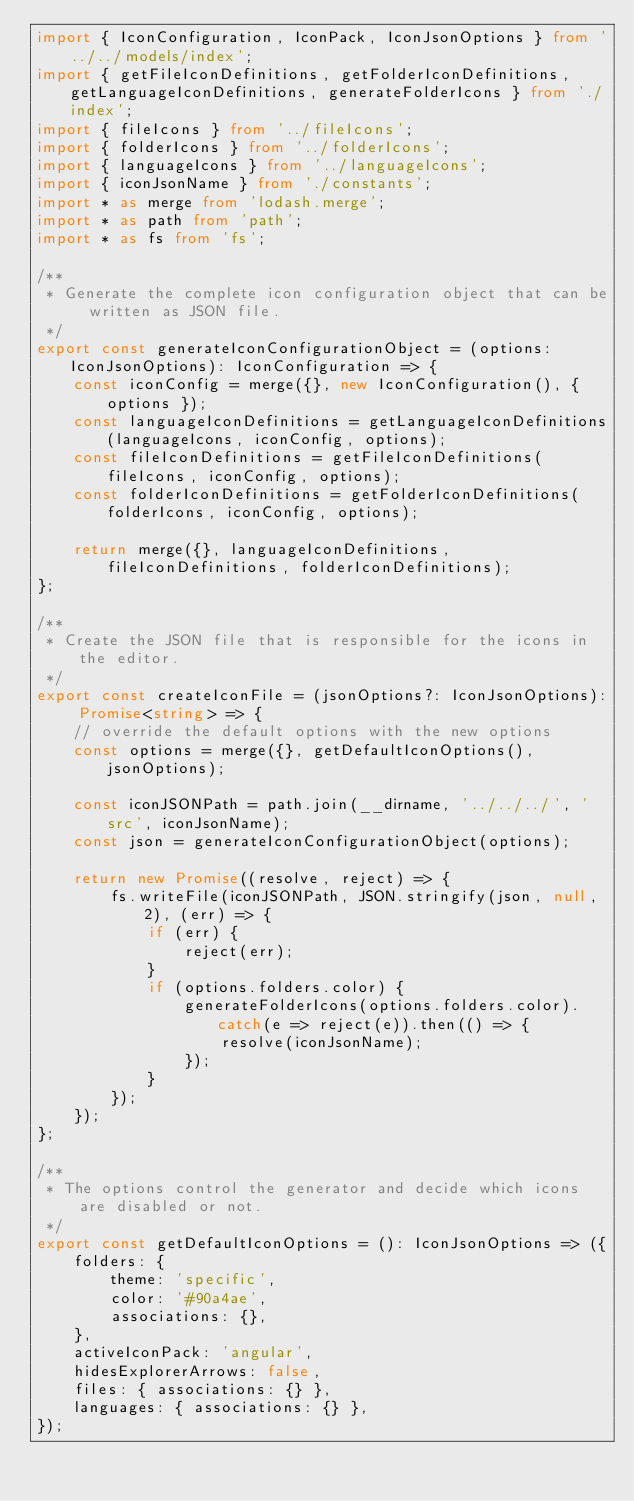Convert code to text. <code><loc_0><loc_0><loc_500><loc_500><_TypeScript_>import { IconConfiguration, IconPack, IconJsonOptions } from '../../models/index';
import { getFileIconDefinitions, getFolderIconDefinitions, getLanguageIconDefinitions, generateFolderIcons } from './index';
import { fileIcons } from '../fileIcons';
import { folderIcons } from '../folderIcons';
import { languageIcons } from '../languageIcons';
import { iconJsonName } from './constants';
import * as merge from 'lodash.merge';
import * as path from 'path';
import * as fs from 'fs';

/**
 * Generate the complete icon configuration object that can be written as JSON file.
 */
export const generateIconConfigurationObject = (options: IconJsonOptions): IconConfiguration => {
    const iconConfig = merge({}, new IconConfiguration(), { options });
    const languageIconDefinitions = getLanguageIconDefinitions(languageIcons, iconConfig, options);
    const fileIconDefinitions = getFileIconDefinitions(fileIcons, iconConfig, options);
    const folderIconDefinitions = getFolderIconDefinitions(folderIcons, iconConfig, options);

    return merge({}, languageIconDefinitions, fileIconDefinitions, folderIconDefinitions);
};

/**
 * Create the JSON file that is responsible for the icons in the editor.
 */
export const createIconFile = (jsonOptions?: IconJsonOptions): Promise<string> => {
    // override the default options with the new options
    const options = merge({}, getDefaultIconOptions(), jsonOptions);

    const iconJSONPath = path.join(__dirname, '../../../', 'src', iconJsonName);
    const json = generateIconConfigurationObject(options);

    return new Promise((resolve, reject) => {
        fs.writeFile(iconJSONPath, JSON.stringify(json, null, 2), (err) => {
            if (err) {
                reject(err);
            }
            if (options.folders.color) {
                generateFolderIcons(options.folders.color).catch(e => reject(e)).then(() => {
                    resolve(iconJsonName);
                });
            }
        });
    });
};

/**
 * The options control the generator and decide which icons are disabled or not.
 */
export const getDefaultIconOptions = (): IconJsonOptions => ({
    folders: {
        theme: 'specific',
        color: '#90a4ae',
        associations: {},
    },
    activeIconPack: 'angular',
    hidesExplorerArrows: false,
    files: { associations: {} },
    languages: { associations: {} },
});
</code> 